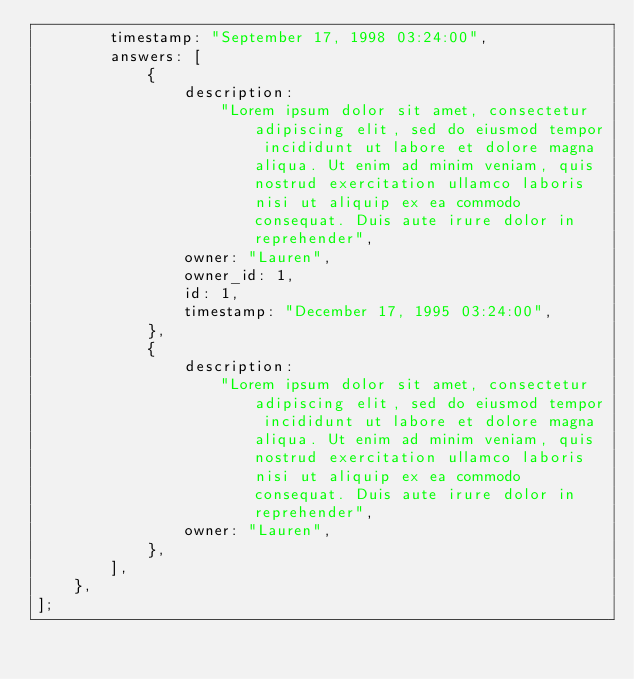Convert code to text. <code><loc_0><loc_0><loc_500><loc_500><_JavaScript_>        timestamp: "September 17, 1998 03:24:00",
        answers: [
            {
                description:
                    "Lorem ipsum dolor sit amet, consectetur adipiscing elit, sed do eiusmod tempor incididunt ut labore et dolore magna aliqua. Ut enim ad minim veniam, quis nostrud exercitation ullamco laboris nisi ut aliquip ex ea commodo consequat. Duis aute irure dolor in reprehender",
                owner: "Lauren",
                owner_id: 1,
                id: 1,
                timestamp: "December 17, 1995 03:24:00",
            },
            {
                description:
                    "Lorem ipsum dolor sit amet, consectetur adipiscing elit, sed do eiusmod tempor incididunt ut labore et dolore magna aliqua. Ut enim ad minim veniam, quis nostrud exercitation ullamco laboris nisi ut aliquip ex ea commodo consequat. Duis aute irure dolor in reprehender",
                owner: "Lauren",
            },
        ],
    },
];</code> 